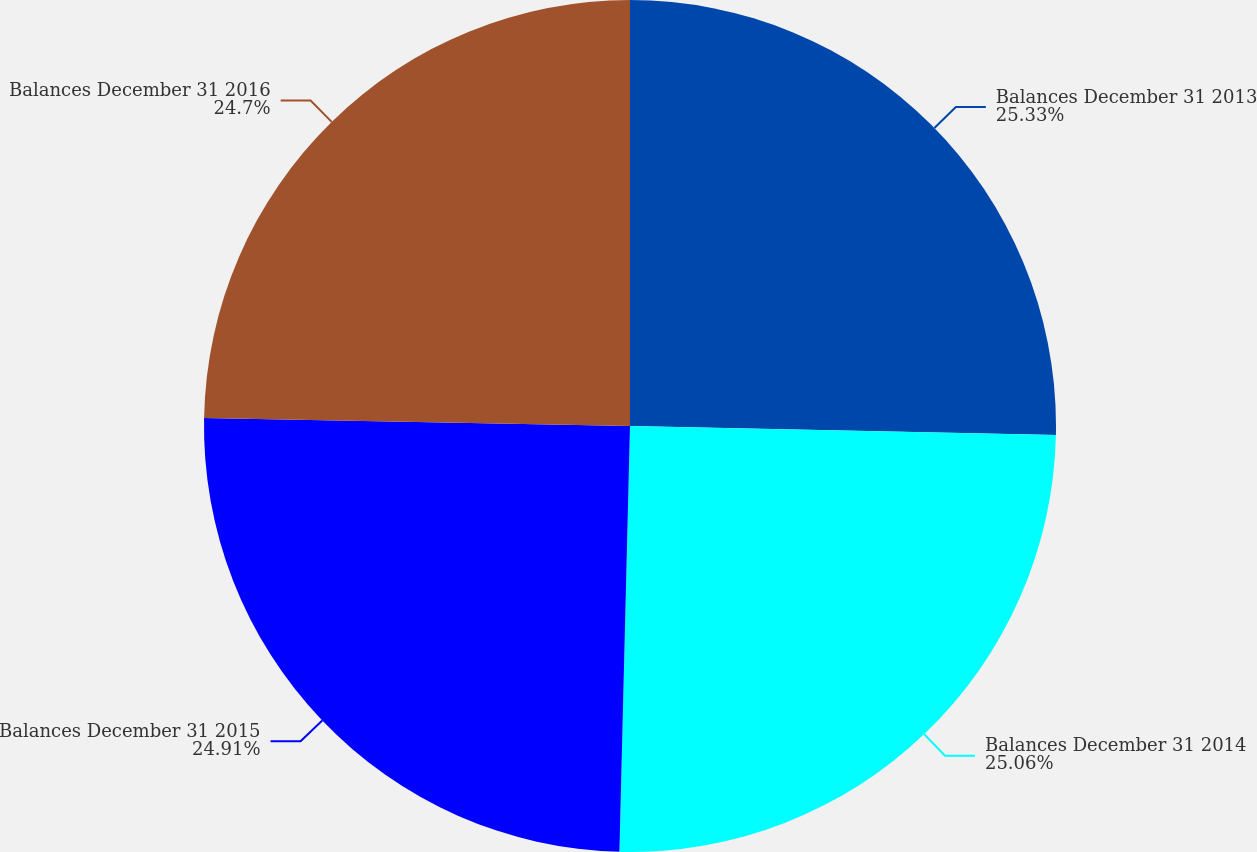Convert chart. <chart><loc_0><loc_0><loc_500><loc_500><pie_chart><fcel>Balances December 31 2013<fcel>Balances December 31 2014<fcel>Balances December 31 2015<fcel>Balances December 31 2016<nl><fcel>25.34%<fcel>25.06%<fcel>24.91%<fcel>24.7%<nl></chart> 